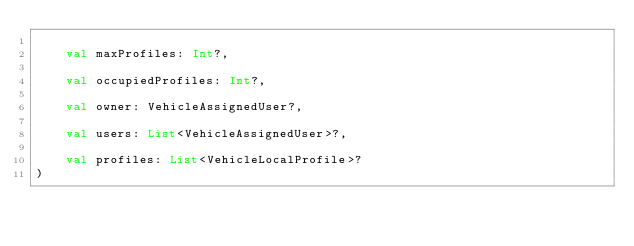<code> <loc_0><loc_0><loc_500><loc_500><_Kotlin_>
    val maxProfiles: Int?,

    val occupiedProfiles: Int?,

    val owner: VehicleAssignedUser?,

    val users: List<VehicleAssignedUser>?,

    val profiles: List<VehicleLocalProfile>?
)
</code> 